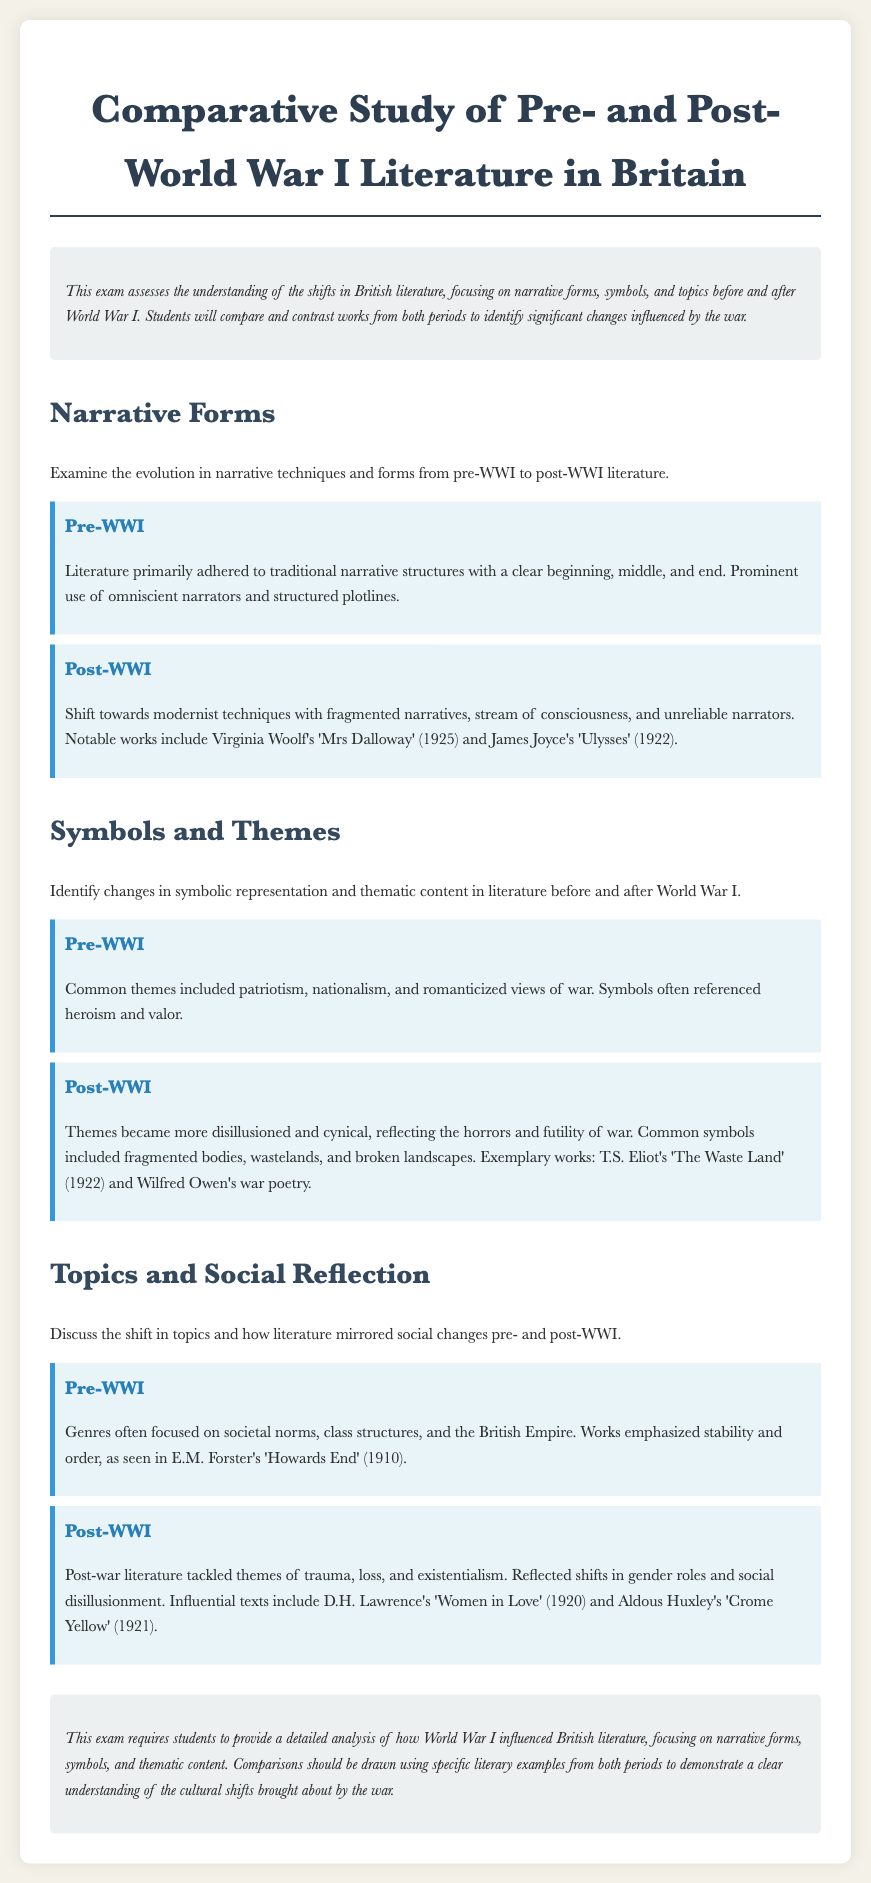What are the prominent narrative techniques mentioned for post-WWI literature? The document states that post-WWI literature features modernist techniques such as fragmented narratives and stream of consciousness.
Answer: fragmented narratives, stream of consciousness Name one example of a pre-WWI literary work. The document includes E.M. Forster's 'Howards End' as an example of pre-WWI literature.
Answer: Howards End What is a common theme in post-WWI literature? The document indicates that themes in post-WWI literature became more disillusioned and cynical, reflecting the horrors of war.
Answer: disillusioned, cynical Which poet is associated with post-WWI symbols of fragmented bodies and wastelands? T.S. Eliot is mentioned for his work 'The Waste Land' that features these symbols.
Answer: T.S. Eliot How did literature topics change after World War I? Post-WWI literature tackled themes of trauma, loss, and existentialism, differing from pre-WWI focus on societal norms and stability.
Answer: trauma, loss, existentialism What literary technique predominantly reflects pre-WWI narrative forms? The document mentions that pre-WWI narratives were characterized by clear beginnings, middles, and ends.
Answer: clear beginnings, middles, and ends Identify a thematic change in literature due to World War I. The thematic content changed from patriotism and nationalism to themes of futility and horror.
Answer: futility, horror Which work is considered an example of war poetry in the post-WWI period? Wilfred Owen's poetry is cited as an example of war poetry from the post-WWI era.
Answer: Wilfred Owen's war poetry 